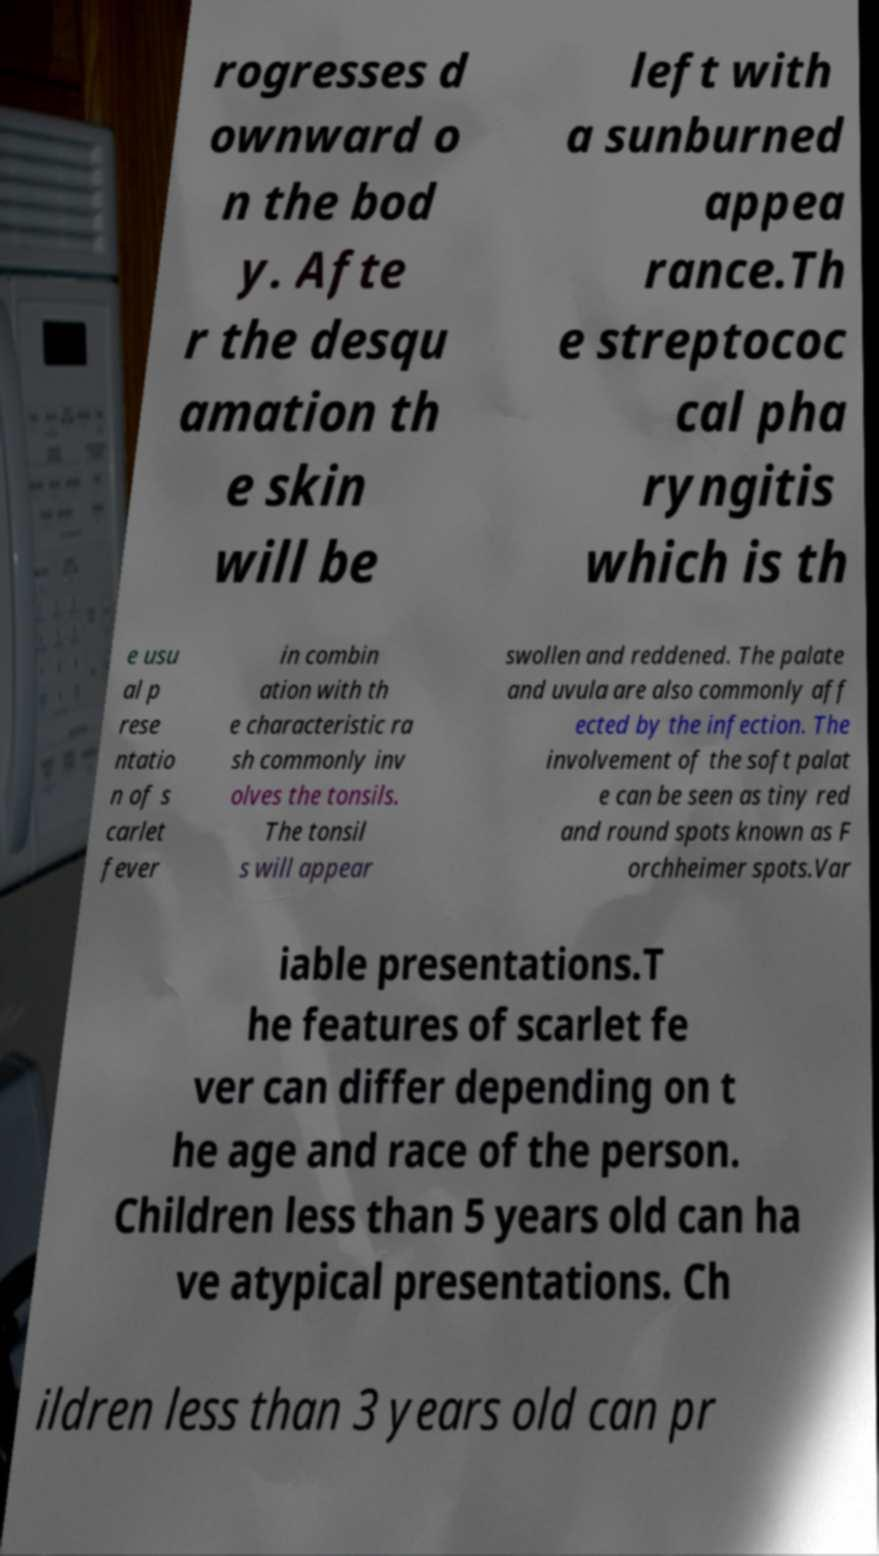Please identify and transcribe the text found in this image. rogresses d ownward o n the bod y. Afte r the desqu amation th e skin will be left with a sunburned appea rance.Th e streptococ cal pha ryngitis which is th e usu al p rese ntatio n of s carlet fever in combin ation with th e characteristic ra sh commonly inv olves the tonsils. The tonsil s will appear swollen and reddened. The palate and uvula are also commonly aff ected by the infection. The involvement of the soft palat e can be seen as tiny red and round spots known as F orchheimer spots.Var iable presentations.T he features of scarlet fe ver can differ depending on t he age and race of the person. Children less than 5 years old can ha ve atypical presentations. Ch ildren less than 3 years old can pr 